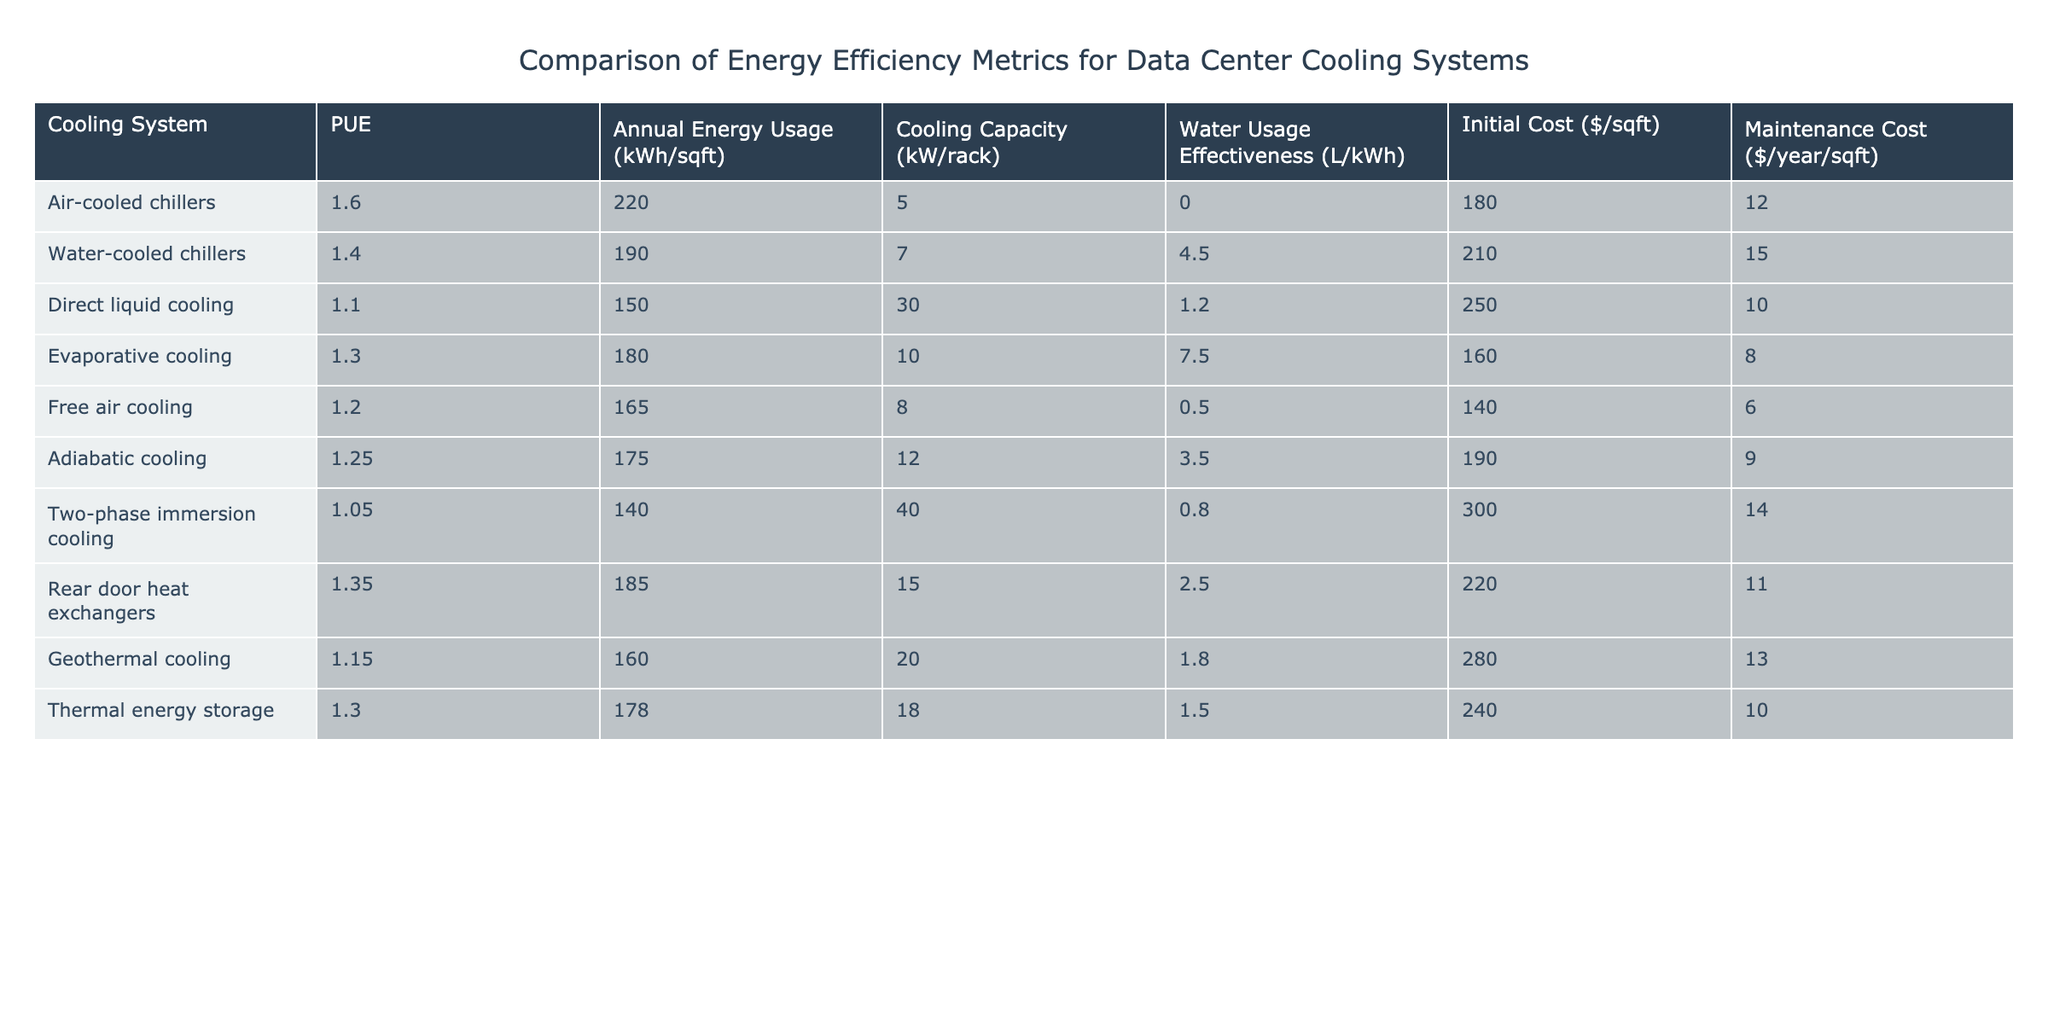What is the PUE of the Direct Liquid Cooling system? According to the table, the PUE value for the Direct Liquid Cooling system is found in its corresponding row under the "PUE" column. The value is 1.1.
Answer: 1.1 Which cooling system has the highest Annual Energy Usage per square foot? Looking at the "Annual Energy Usage (kWh/sqft)" column, the highest value can be identified. The Air-cooled chillers have the highest annual energy usage at 220 kWh/sqft.
Answer: 220 kWh/sqft What is the Water Usage Effectiveness for the Evaporative Cooling system? Referring to the table and finding the row for Evaporative Cooling, the corresponding "Water Usage Effectiveness (L/kWh)" value is 7.5.
Answer: 7.5 Which cooling system has the lowest Initial Cost per square foot? By checking the "Initial Cost ($/sqft)" column, the system with the lowest value is Free Air Cooling at $140/sqft.
Answer: $140/sqft How much more maintenance cost is associated with Water-cooled chillers compared to Free air cooling? Look at the "Maintenance Cost ($/year/sqft)" for both systems. Water-cooled chillers cost $15/year/sqft, and Free air cooling costs $6/year/sqft. The difference is $15 - $6 = $9.
Answer: $9 Is the Cooling Capacity of Direct Liquid Cooling greater than that of Water-cooled chillers? Checking the "Cooling Capacity (kW/rack)" column, Direct Liquid Cooling shows 30 kW/rack and Water-cooled chillers show 7 kW/rack. Since 30 > 7, the statement is true.
Answer: Yes What is the average Annual Energy Usage for all the cooling systems listed? To find the average, sum the values from the "Annual Energy Usage (kWh/sqft)" column (220 + 190 + 150 + 180 + 165 + 175 + 140 + 185 + 160 + 178 = 1880) and divide by the number of systems (10). Therefore, the average is 1880 / 10 = 188.
Answer: 188 kWh/sqft Which cooling system has the best Water Usage Effectiveness among systems with PUE greater than 1.3? First, identify the systems with PUE greater than 1.3: Air-cooled chillers, Water-cooled chillers, Evaporative cooling, and Rear door heat exchangers. Their Water Usage Effectiveness values are 0, 4.5, 7.5, and 2.5 respectively. The best (lowest) is Water-cooled chillers at 4.5 L/kWh.
Answer: 4.5 L/kWh What is the total Maintenance Cost for the Two-phase immersion cooling and Direct Liquid Cooling systems combined? The maintenance costs are: Two-phase immersion cooling is $14/year/sqft and Direct Liquid Cooling is $10/year/sqft. Therefore, the total cost is $14 + $10 = $24.
Answer: $24 Does the Free Air Cooling system offer a lower Cooling Capacity compared to Adiabatic cooling? Comparing their Cooling Capacity values, Free Air Cooling has 8 kW/rack, and Adiabatic cooling has 12 kW/rack. Since 8 < 12, the statement is true.
Answer: Yes 